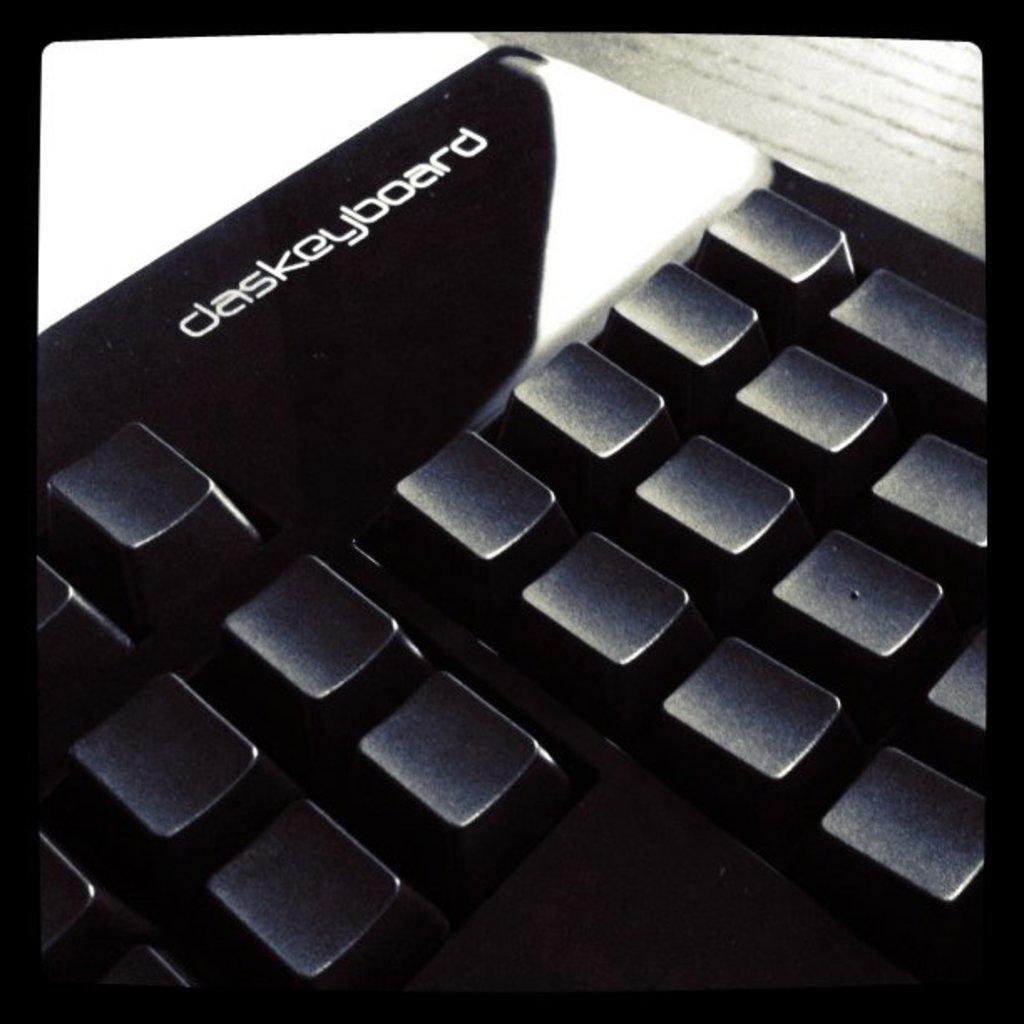How would you summarize this image in a sentence or two? In this image we can see a keyboard placed on the table. 